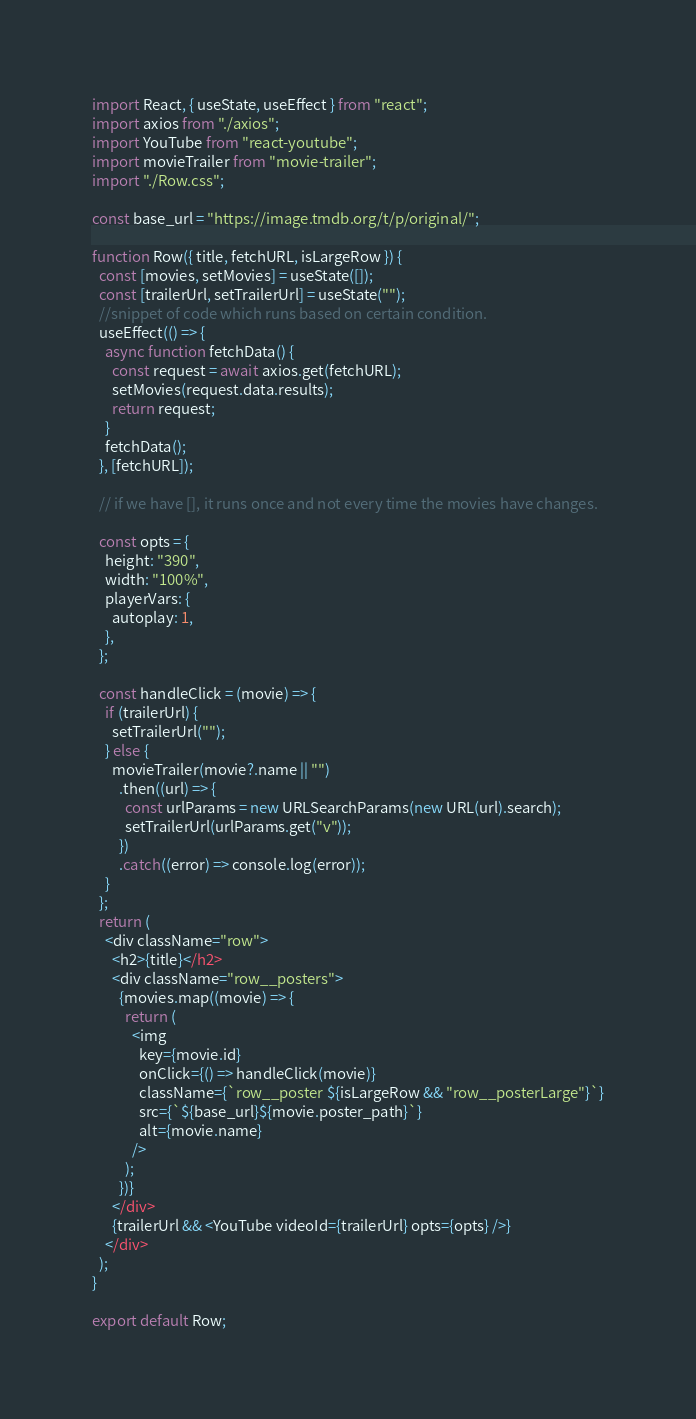<code> <loc_0><loc_0><loc_500><loc_500><_JavaScript_>import React, { useState, useEffect } from "react";
import axios from "./axios";
import YouTube from "react-youtube";
import movieTrailer from "movie-trailer";
import "./Row.css";

const base_url = "https://image.tmdb.org/t/p/original/";

function Row({ title, fetchURL, isLargeRow }) {
  const [movies, setMovies] = useState([]);
  const [trailerUrl, setTrailerUrl] = useState("");
  //snippet of code which runs based on certain condition.
  useEffect(() => {
    async function fetchData() {
      const request = await axios.get(fetchURL);
      setMovies(request.data.results);
      return request;
    }
    fetchData();
  }, [fetchURL]);

  // if we have [], it runs once and not every time the movies have changes.

  const opts = {
    height: "390",
    width: "100%",
    playerVars: {
      autoplay: 1,
    },
  };

  const handleClick = (movie) => {
    if (trailerUrl) {
      setTrailerUrl("");
    } else {
      movieTrailer(movie?.name || "")
        .then((url) => {
          const urlParams = new URLSearchParams(new URL(url).search);
          setTrailerUrl(urlParams.get("v"));
        })
        .catch((error) => console.log(error));
    }
  };
  return (
    <div className="row">
      <h2>{title}</h2>
      <div className="row__posters">
        {movies.map((movie) => {
          return (
            <img
              key={movie.id}
              onClick={() => handleClick(movie)}
              className={`row__poster ${isLargeRow && "row__posterLarge"}`}
              src={`${base_url}${movie.poster_path}`}
              alt={movie.name}
            />
          );
        })}
      </div>
      {trailerUrl && <YouTube videoId={trailerUrl} opts={opts} />}
    </div>
  );
}

export default Row;
</code> 